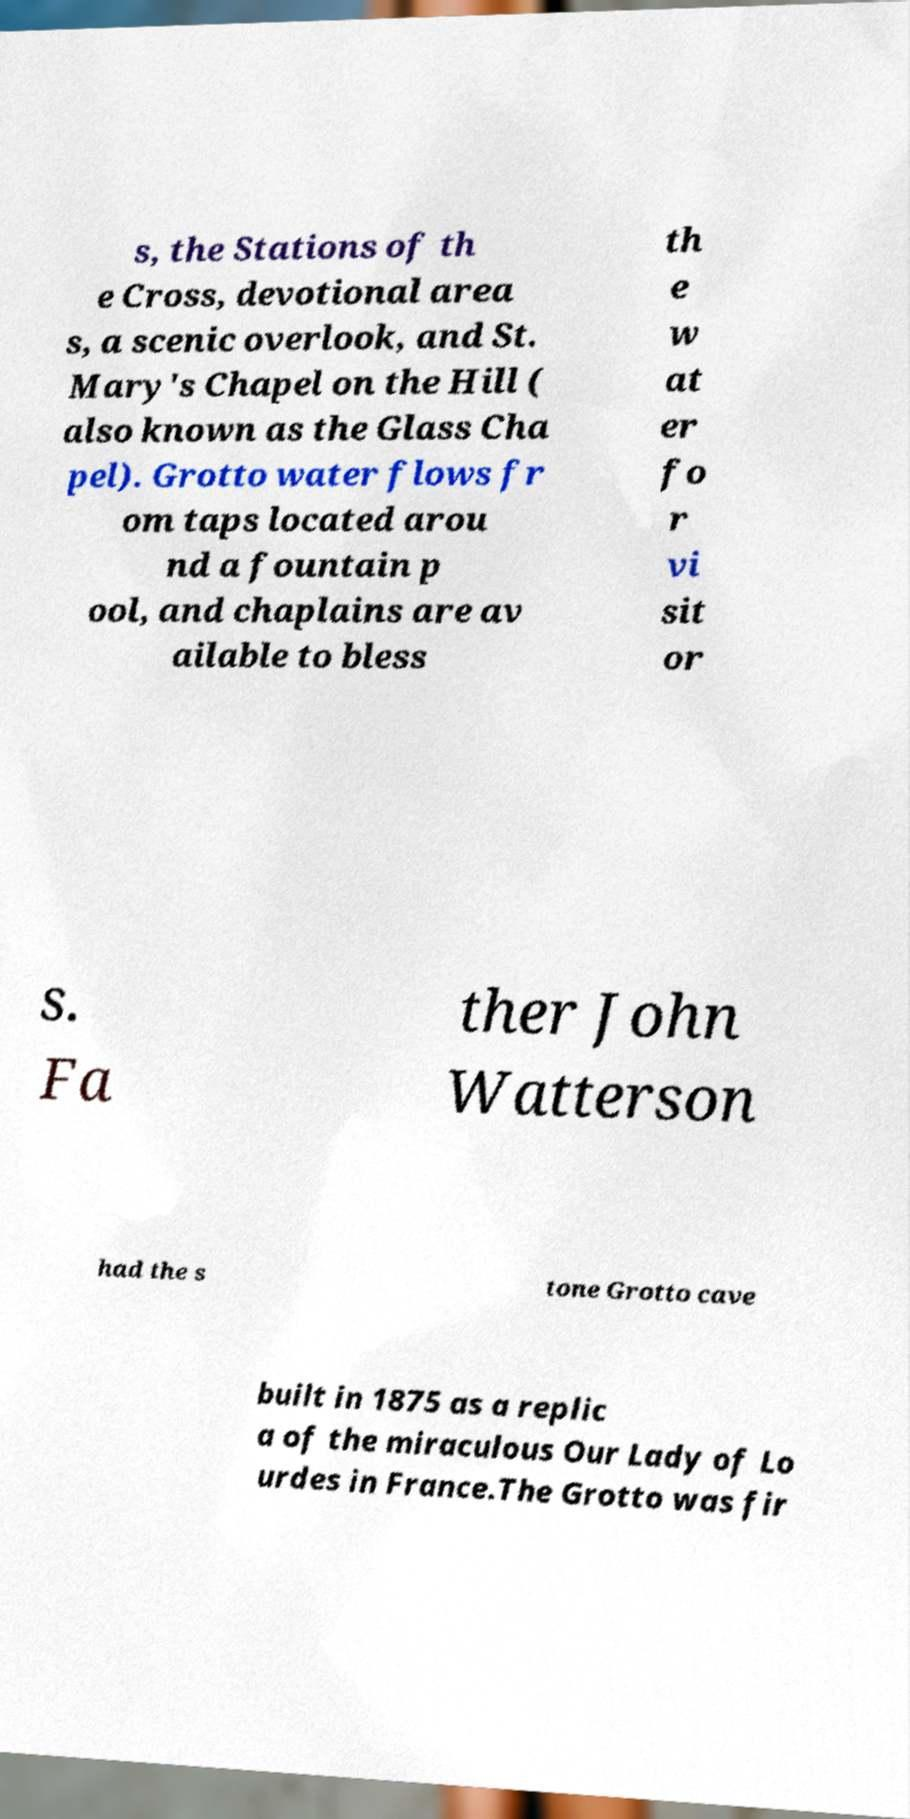What messages or text are displayed in this image? I need them in a readable, typed format. s, the Stations of th e Cross, devotional area s, a scenic overlook, and St. Mary's Chapel on the Hill ( also known as the Glass Cha pel). Grotto water flows fr om taps located arou nd a fountain p ool, and chaplains are av ailable to bless th e w at er fo r vi sit or s. Fa ther John Watterson had the s tone Grotto cave built in 1875 as a replic a of the miraculous Our Lady of Lo urdes in France.The Grotto was fir 